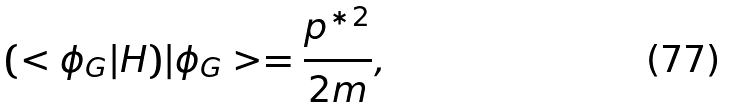<formula> <loc_0><loc_0><loc_500><loc_500>( < \phi _ { G } | H ) | \phi _ { G } > = \frac { p ^ { \ast 2 } } { 2 m } ,</formula> 